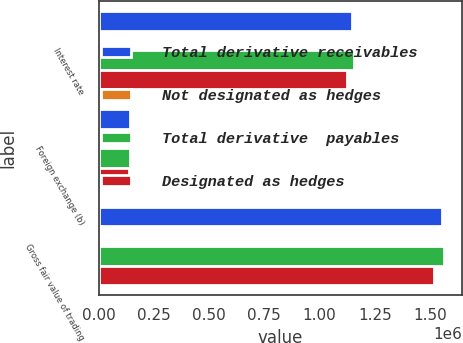Convert chart. <chart><loc_0><loc_0><loc_500><loc_500><stacked_bar_chart><ecel><fcel>Interest rate<fcel>Foreign exchange (b)<fcel>Gross fair value of trading<nl><fcel>Total derivative receivables<fcel>1.1489e+06<fcel>141790<fcel>1.55641e+06<nl><fcel>Not designated as hedges<fcel>6568<fcel>2497<fcel>9104<nl><fcel>Total derivative  payables<fcel>1.15547e+06<fcel>144287<fcel>1.56552e+06<nl><fcel>Designated as hedges<fcel>1.1224e+06<fcel>138218<fcel>1.51918e+06<nl></chart> 